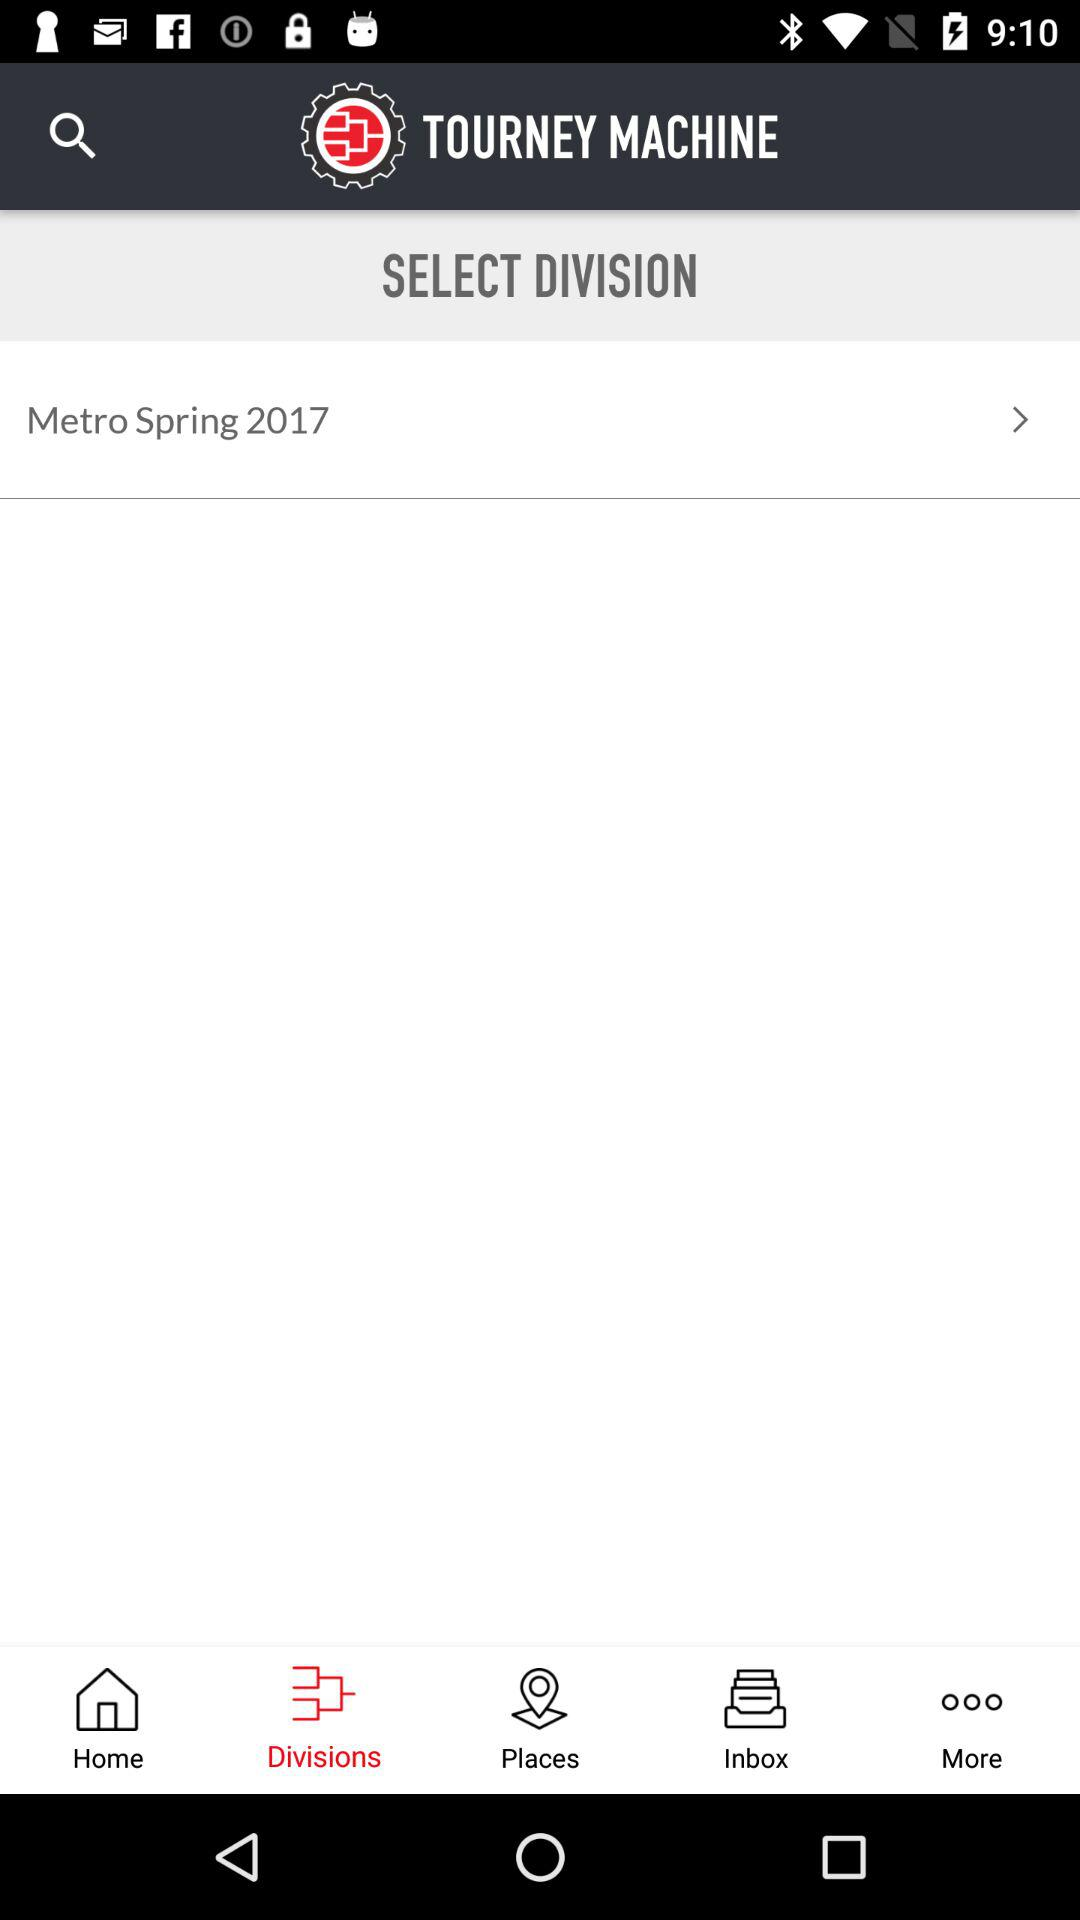Which option is selected? The selected option is "Divisions". 